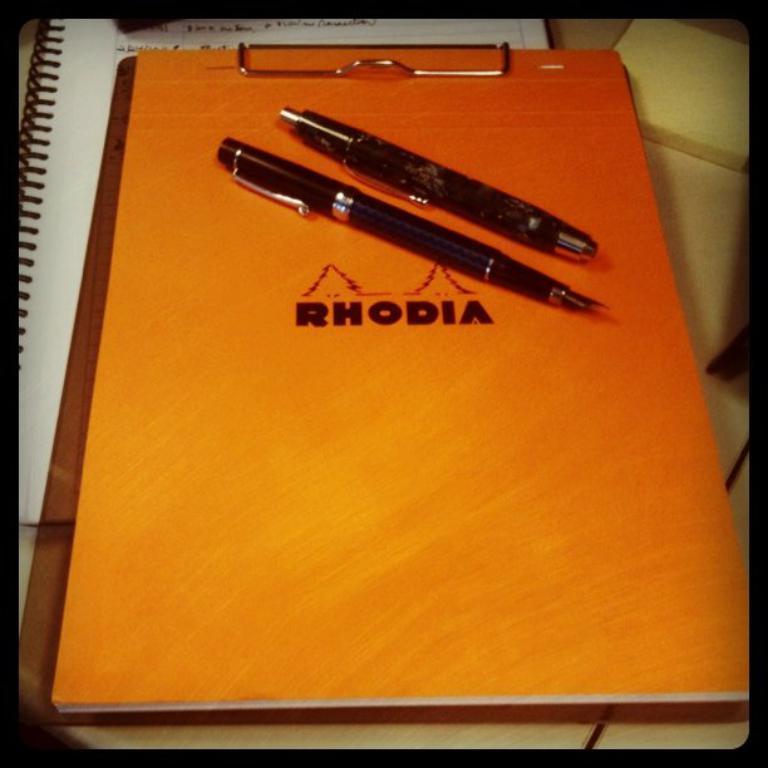In one or two sentences, can you explain what this image depicts? In this picture we can see a book and pens on an exam pad. Under this exam pad, we can see a notepad. 